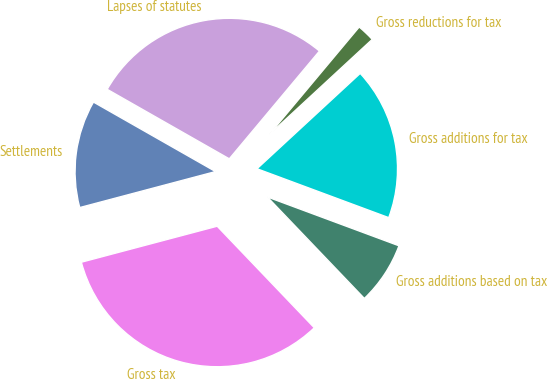Convert chart. <chart><loc_0><loc_0><loc_500><loc_500><pie_chart><fcel>Gross tax<fcel>Gross additions based on tax<fcel>Gross additions for tax<fcel>Gross reductions for tax<fcel>Lapses of statutes<fcel>Settlements<nl><fcel>33.02%<fcel>7.2%<fcel>17.53%<fcel>2.04%<fcel>27.85%<fcel>12.36%<nl></chart> 